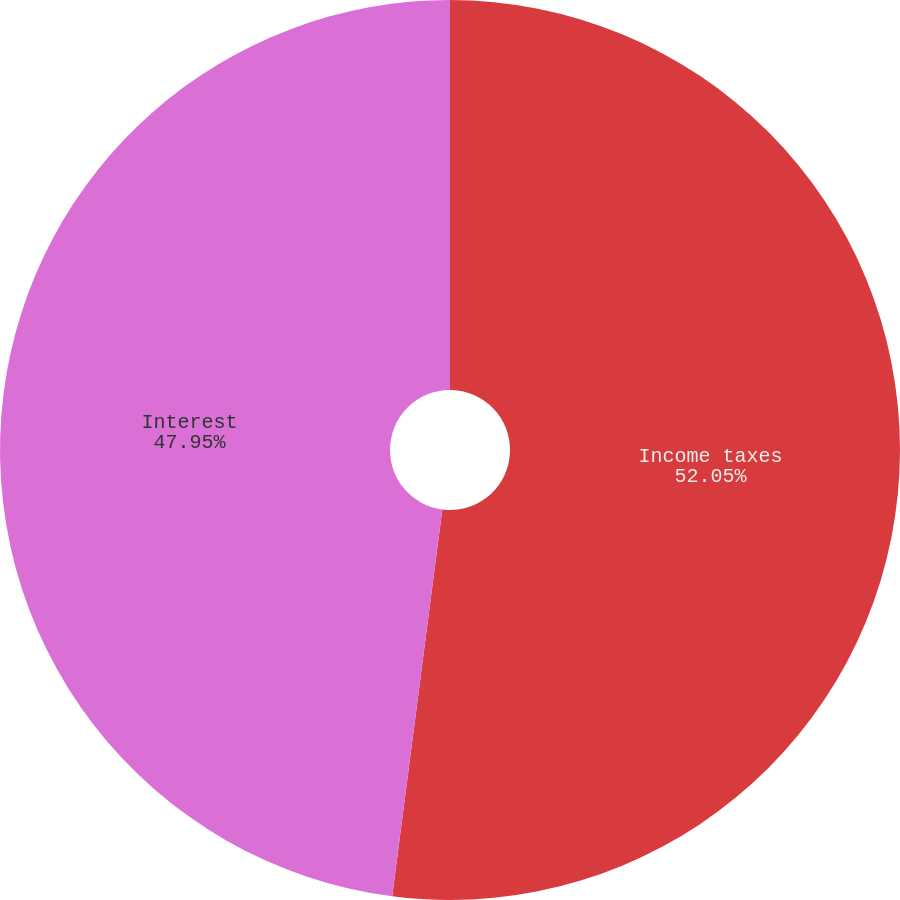Convert chart to OTSL. <chart><loc_0><loc_0><loc_500><loc_500><pie_chart><fcel>Income taxes<fcel>Interest<nl><fcel>52.05%<fcel>47.95%<nl></chart> 